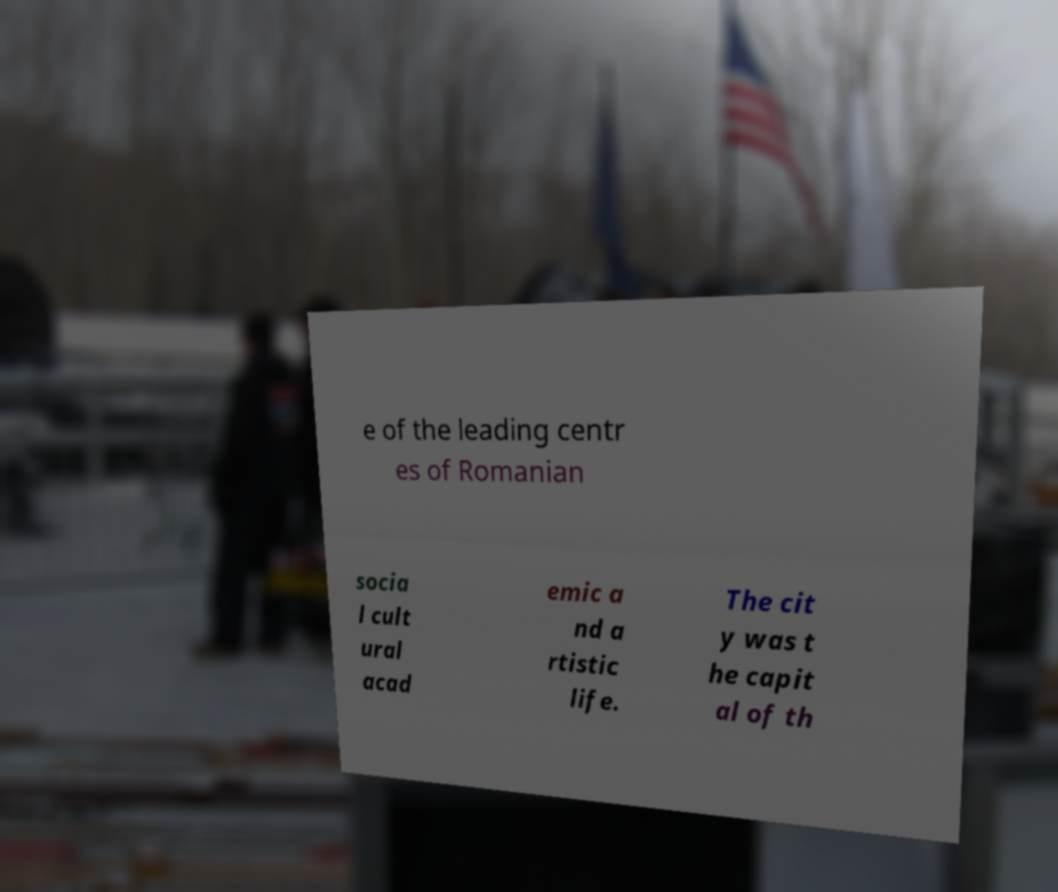Please identify and transcribe the text found in this image. e of the leading centr es of Romanian socia l cult ural acad emic a nd a rtistic life. The cit y was t he capit al of th 